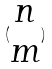Convert formula to latex. <formula><loc_0><loc_0><loc_500><loc_500>( \begin{matrix} n \\ m \end{matrix} )</formula> 